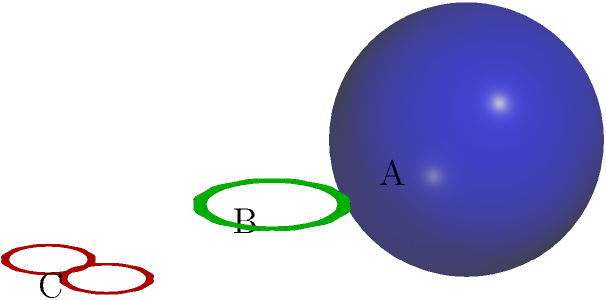As a prospective student interested in topology at Blair, you're asked to classify the surfaces A, B, and C based on their genus. Which of these statements is correct?

a) A has genus 0, B has genus 1, and C has genus 2
b) A has genus 1, B has genus 2, and C has genus 3
c) A has genus 0, B has genus 2, and C has genus 3
d) A has genus 1, B has genus 1, and C has genus 2 To answer this question, we need to understand the concept of genus and how to identify it for different surfaces:

1. The genus of a surface is the number of "holes" or "handles" it has.

2. Surface A is a sphere. A sphere has no holes, so its genus is 0.

3. Surface B is a torus (donut shape). A torus has one hole, so its genus is 1.

4. Surface C is a double torus, which has two holes. Therefore, its genus is 2.

5. We can also use the Euler characteristic formula: $\chi = 2 - 2g$, where $\chi$ is the Euler characteristic and $g$ is the genus. For a sphere, $\chi = 2$, for a torus, $\chi = 0$, and for a double torus, $\chi = -2$.

6. Comparing our analysis with the given options, we can see that option a) correctly describes the genus of each surface.

Therefore, the correct answer is option a): A has genus 0, B has genus 1, and C has genus 2.
Answer: a) A has genus 0, B has genus 1, and C has genus 2 